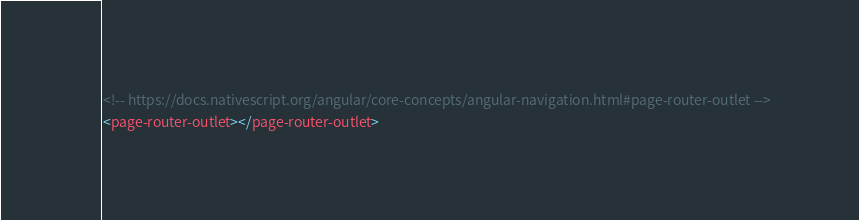<code> <loc_0><loc_0><loc_500><loc_500><_HTML_><!-- https://docs.nativescript.org/angular/core-concepts/angular-navigation.html#page-router-outlet -->
<page-router-outlet></page-router-outlet>





</code> 